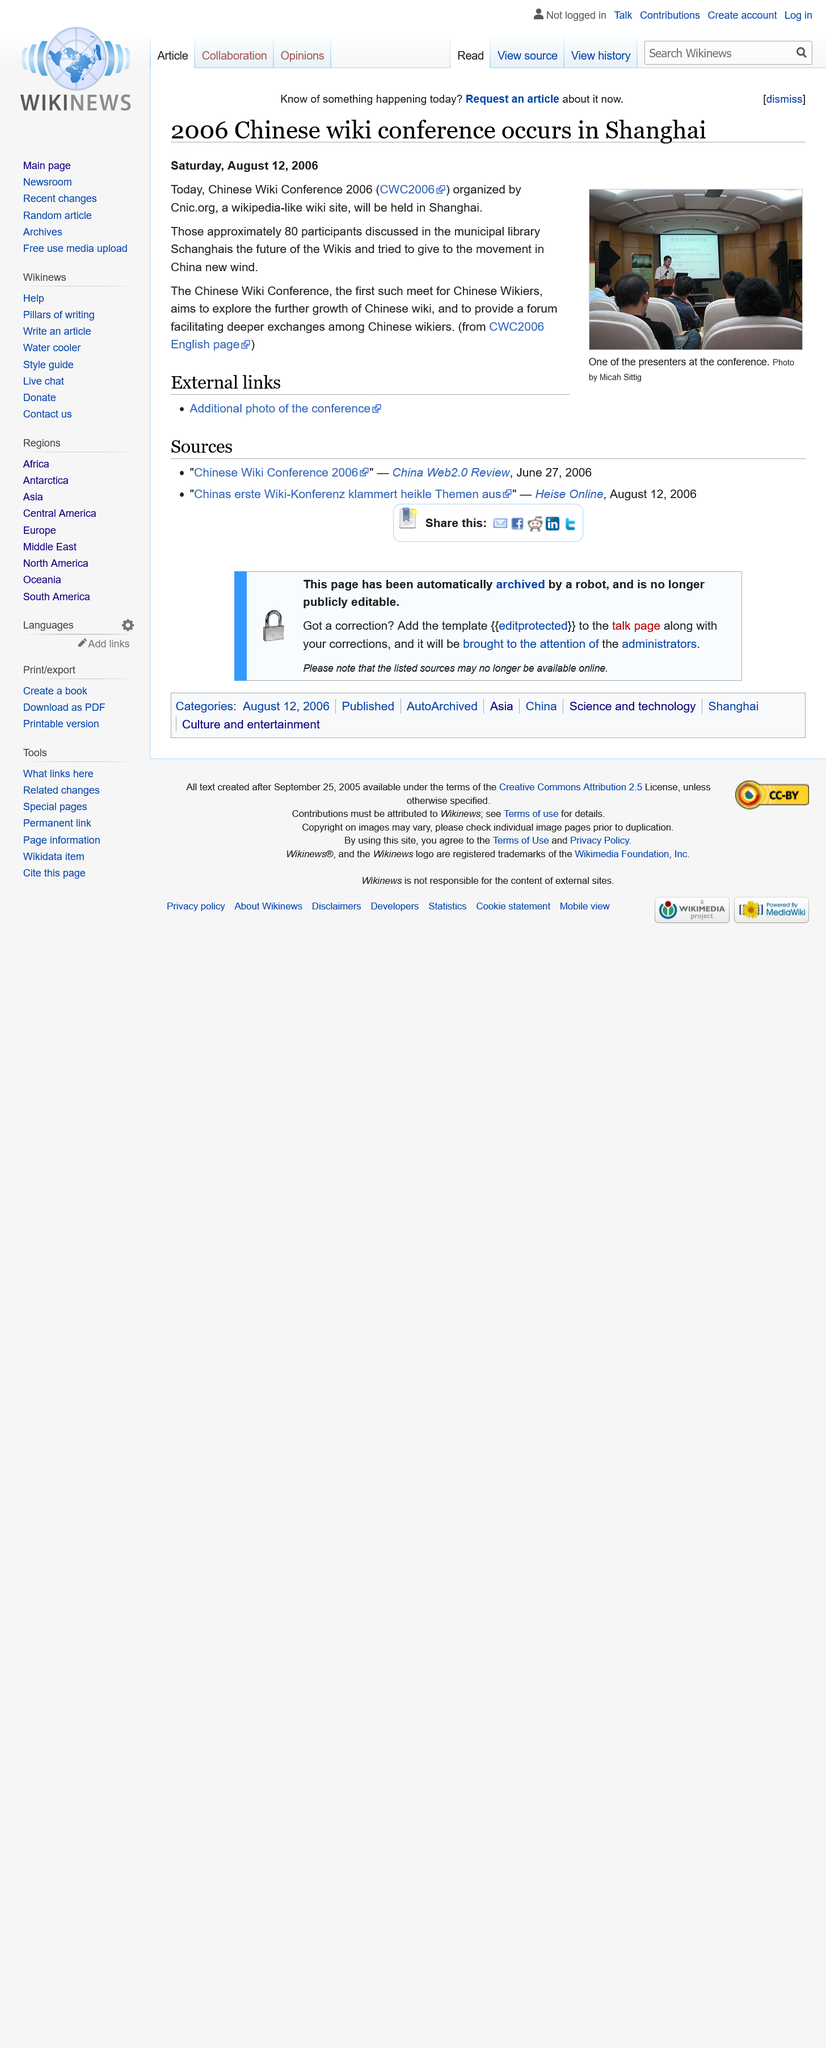Identify some key points in this picture. The 2006 Chinese Wiki Conference was held in Shanghai. The Chinese Wiki Conference was the first such event for Chinese Wikiers, as there had not been a previous Chinese Wiki Conference. There were approximately 80 participants at the 2006 Chinese Wiki Conference. 